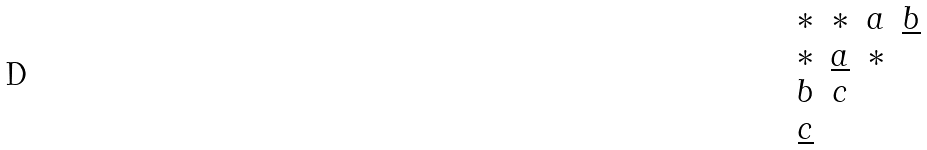Convert formula to latex. <formula><loc_0><loc_0><loc_500><loc_500>\begin{matrix} * & * & a & \underline { b } \\ * & \underline { a } & * & \\ b & c & & \\ \underline { c } & & & \end{matrix}</formula> 